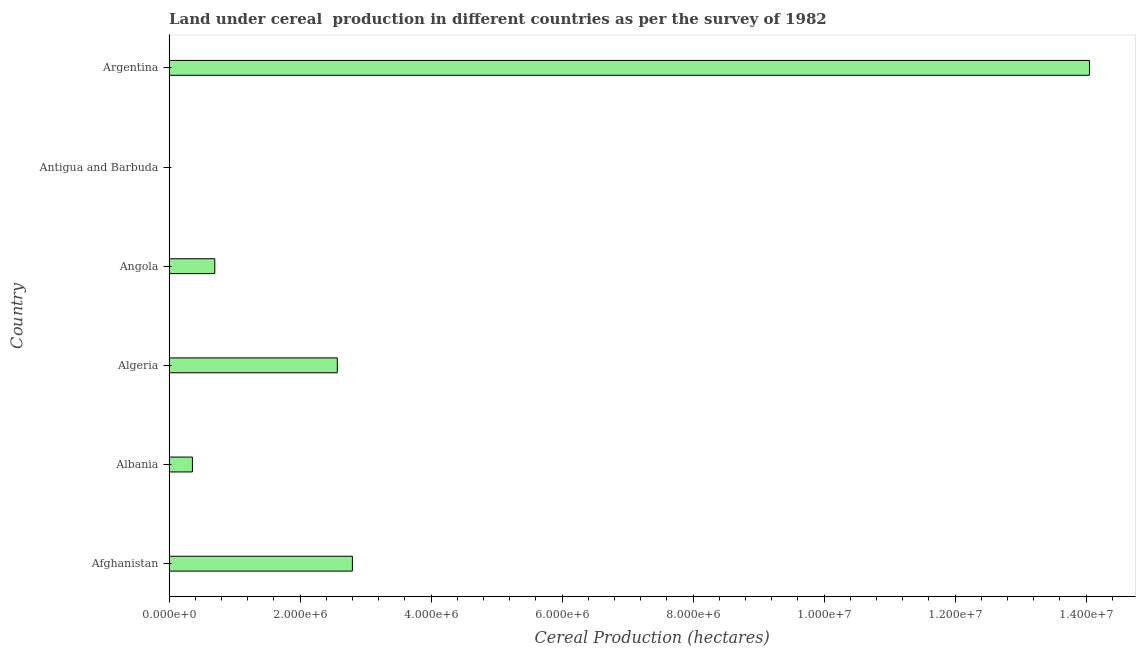What is the title of the graph?
Provide a short and direct response. Land under cereal  production in different countries as per the survey of 1982. What is the label or title of the X-axis?
Your response must be concise. Cereal Production (hectares). What is the land under cereal production in Albania?
Offer a very short reply. 3.57e+05. Across all countries, what is the maximum land under cereal production?
Give a very brief answer. 1.41e+07. Across all countries, what is the minimum land under cereal production?
Ensure brevity in your answer.  33. In which country was the land under cereal production maximum?
Offer a very short reply. Argentina. In which country was the land under cereal production minimum?
Keep it short and to the point. Antigua and Barbuda. What is the sum of the land under cereal production?
Provide a succinct answer. 2.05e+07. What is the difference between the land under cereal production in Angola and Argentina?
Your answer should be compact. -1.34e+07. What is the average land under cereal production per country?
Make the answer very short. 3.41e+06. What is the median land under cereal production?
Your answer should be compact. 1.63e+06. What is the ratio of the land under cereal production in Antigua and Barbuda to that in Argentina?
Make the answer very short. 0. Is the land under cereal production in Afghanistan less than that in Algeria?
Provide a short and direct response. No. Is the difference between the land under cereal production in Algeria and Angola greater than the difference between any two countries?
Make the answer very short. No. What is the difference between the highest and the second highest land under cereal production?
Offer a terse response. 1.13e+07. Is the sum of the land under cereal production in Angola and Argentina greater than the maximum land under cereal production across all countries?
Make the answer very short. Yes. What is the difference between the highest and the lowest land under cereal production?
Your answer should be very brief. 1.41e+07. How many bars are there?
Ensure brevity in your answer.  6. What is the Cereal Production (hectares) in Afghanistan?
Offer a terse response. 2.80e+06. What is the Cereal Production (hectares) of Albania?
Give a very brief answer. 3.57e+05. What is the Cereal Production (hectares) in Algeria?
Make the answer very short. 2.57e+06. What is the Cereal Production (hectares) of Angola?
Provide a short and direct response. 6.99e+05. What is the Cereal Production (hectares) in Argentina?
Your answer should be compact. 1.41e+07. What is the difference between the Cereal Production (hectares) in Afghanistan and Albania?
Make the answer very short. 2.44e+06. What is the difference between the Cereal Production (hectares) in Afghanistan and Algeria?
Give a very brief answer. 2.30e+05. What is the difference between the Cereal Production (hectares) in Afghanistan and Angola?
Your answer should be compact. 2.10e+06. What is the difference between the Cereal Production (hectares) in Afghanistan and Antigua and Barbuda?
Provide a succinct answer. 2.80e+06. What is the difference between the Cereal Production (hectares) in Afghanistan and Argentina?
Make the answer very short. -1.13e+07. What is the difference between the Cereal Production (hectares) in Albania and Algeria?
Ensure brevity in your answer.  -2.21e+06. What is the difference between the Cereal Production (hectares) in Albania and Angola?
Your answer should be very brief. -3.42e+05. What is the difference between the Cereal Production (hectares) in Albania and Antigua and Barbuda?
Give a very brief answer. 3.57e+05. What is the difference between the Cereal Production (hectares) in Albania and Argentina?
Ensure brevity in your answer.  -1.37e+07. What is the difference between the Cereal Production (hectares) in Algeria and Angola?
Offer a very short reply. 1.87e+06. What is the difference between the Cereal Production (hectares) in Algeria and Antigua and Barbuda?
Give a very brief answer. 2.57e+06. What is the difference between the Cereal Production (hectares) in Algeria and Argentina?
Keep it short and to the point. -1.15e+07. What is the difference between the Cereal Production (hectares) in Angola and Antigua and Barbuda?
Your answer should be compact. 6.99e+05. What is the difference between the Cereal Production (hectares) in Angola and Argentina?
Your response must be concise. -1.34e+07. What is the difference between the Cereal Production (hectares) in Antigua and Barbuda and Argentina?
Provide a short and direct response. -1.41e+07. What is the ratio of the Cereal Production (hectares) in Afghanistan to that in Albania?
Make the answer very short. 7.83. What is the ratio of the Cereal Production (hectares) in Afghanistan to that in Algeria?
Your response must be concise. 1.09. What is the ratio of the Cereal Production (hectares) in Afghanistan to that in Angola?
Offer a very short reply. 4. What is the ratio of the Cereal Production (hectares) in Afghanistan to that in Antigua and Barbuda?
Make the answer very short. 8.48e+04. What is the ratio of the Cereal Production (hectares) in Afghanistan to that in Argentina?
Your response must be concise. 0.2. What is the ratio of the Cereal Production (hectares) in Albania to that in Algeria?
Your answer should be compact. 0.14. What is the ratio of the Cereal Production (hectares) in Albania to that in Angola?
Offer a terse response. 0.51. What is the ratio of the Cereal Production (hectares) in Albania to that in Antigua and Barbuda?
Provide a short and direct response. 1.08e+04. What is the ratio of the Cereal Production (hectares) in Albania to that in Argentina?
Keep it short and to the point. 0.03. What is the ratio of the Cereal Production (hectares) in Algeria to that in Angola?
Give a very brief answer. 3.68. What is the ratio of the Cereal Production (hectares) in Algeria to that in Antigua and Barbuda?
Ensure brevity in your answer.  7.79e+04. What is the ratio of the Cereal Production (hectares) in Algeria to that in Argentina?
Offer a very short reply. 0.18. What is the ratio of the Cereal Production (hectares) in Angola to that in Antigua and Barbuda?
Your answer should be very brief. 2.12e+04. What is the ratio of the Cereal Production (hectares) in Angola to that in Argentina?
Provide a succinct answer. 0.05. What is the ratio of the Cereal Production (hectares) in Antigua and Barbuda to that in Argentina?
Keep it short and to the point. 0. 